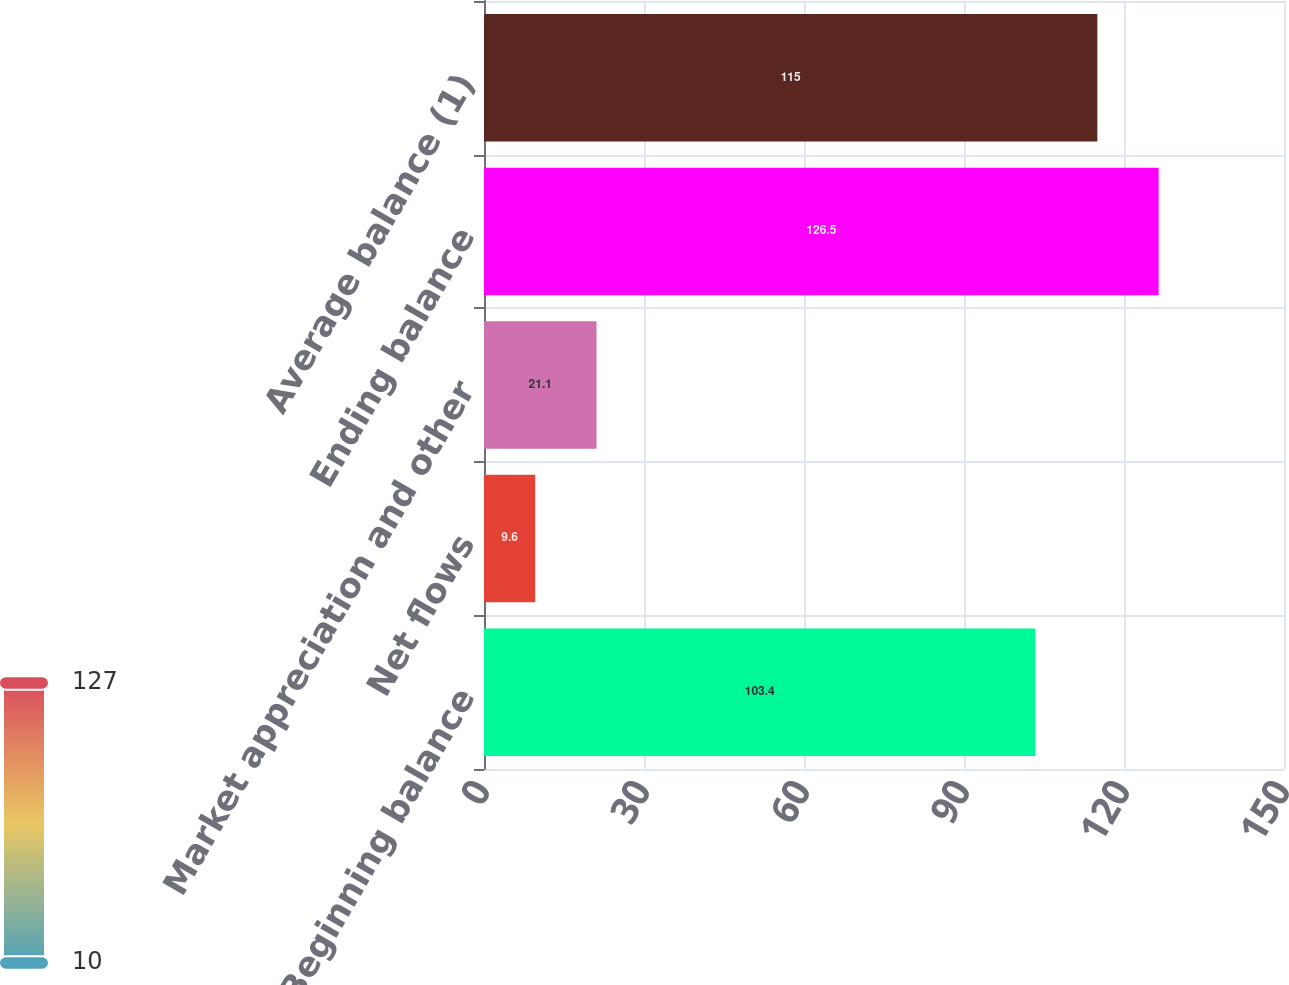Convert chart to OTSL. <chart><loc_0><loc_0><loc_500><loc_500><bar_chart><fcel>Beginning balance<fcel>Net flows<fcel>Market appreciation and other<fcel>Ending balance<fcel>Average balance (1)<nl><fcel>103.4<fcel>9.6<fcel>21.1<fcel>126.5<fcel>115<nl></chart> 